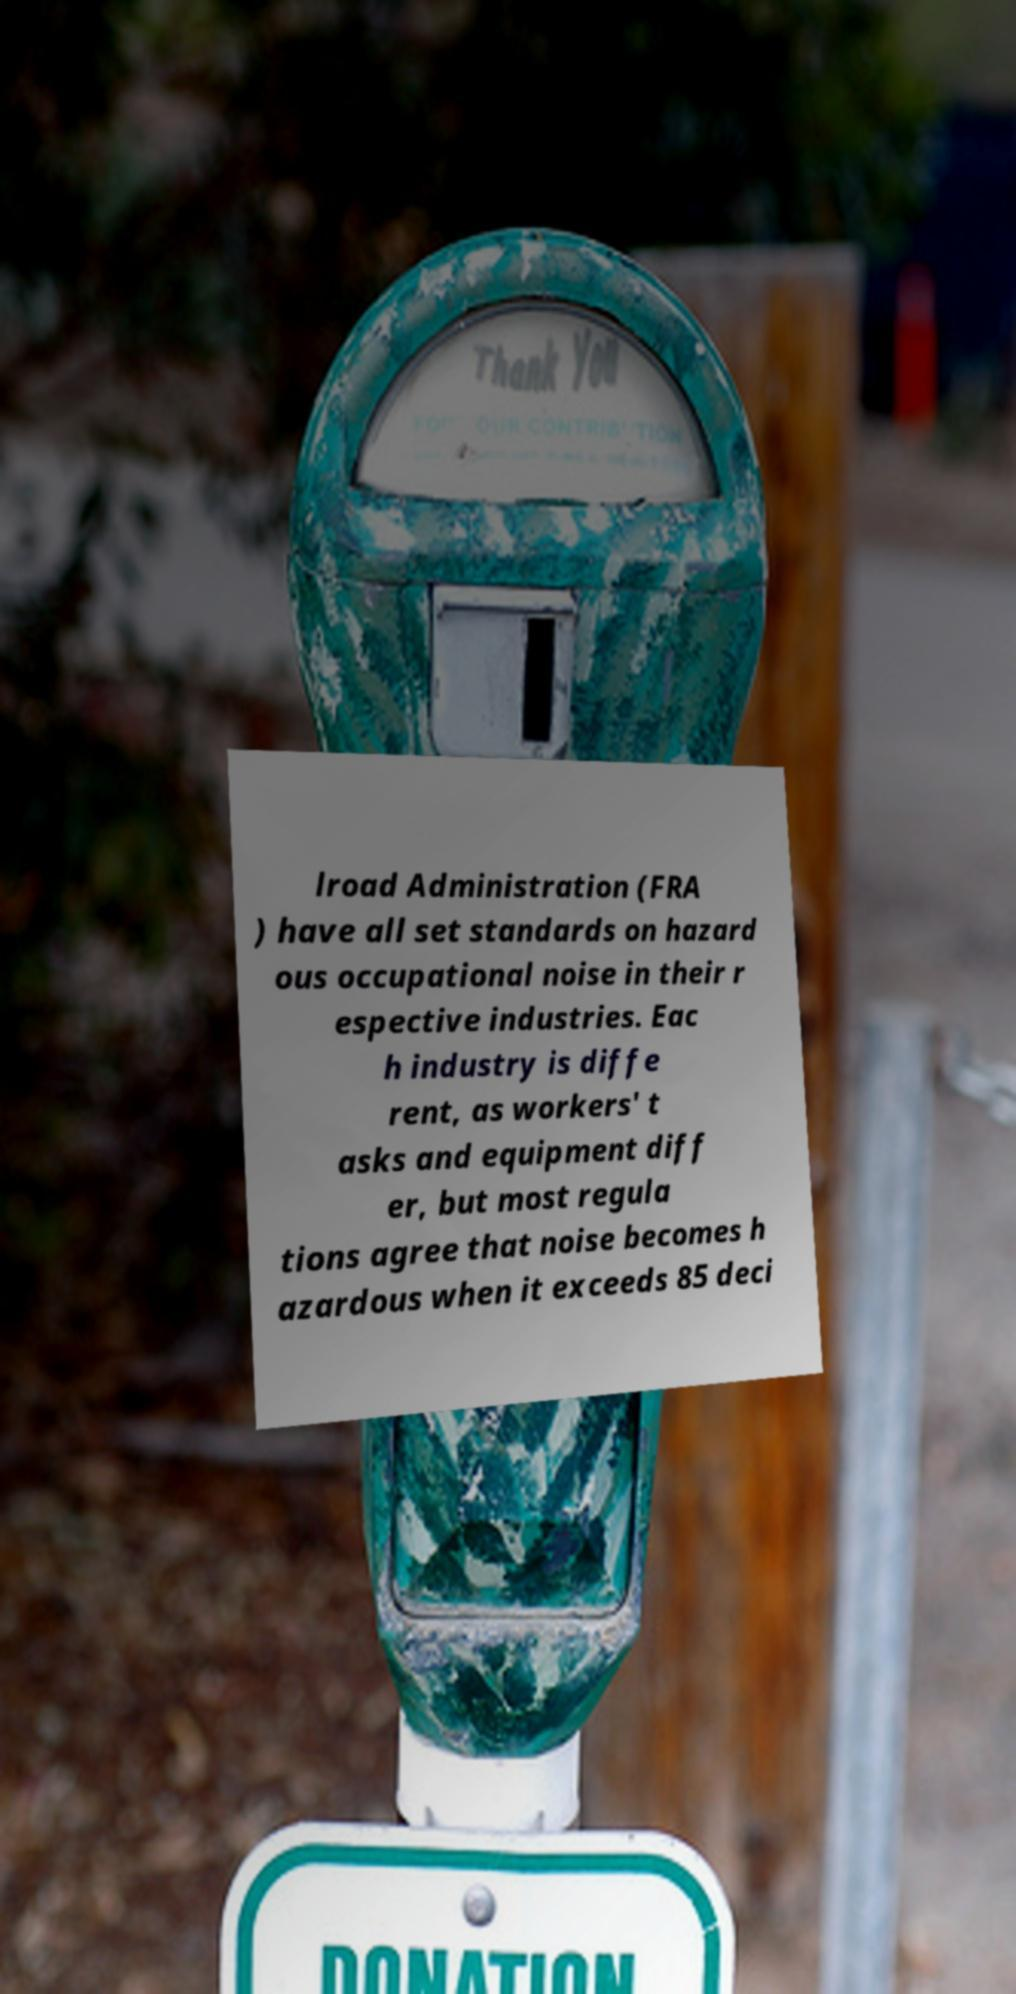Please identify and transcribe the text found in this image. lroad Administration (FRA ) have all set standards on hazard ous occupational noise in their r espective industries. Eac h industry is diffe rent, as workers' t asks and equipment diff er, but most regula tions agree that noise becomes h azardous when it exceeds 85 deci 